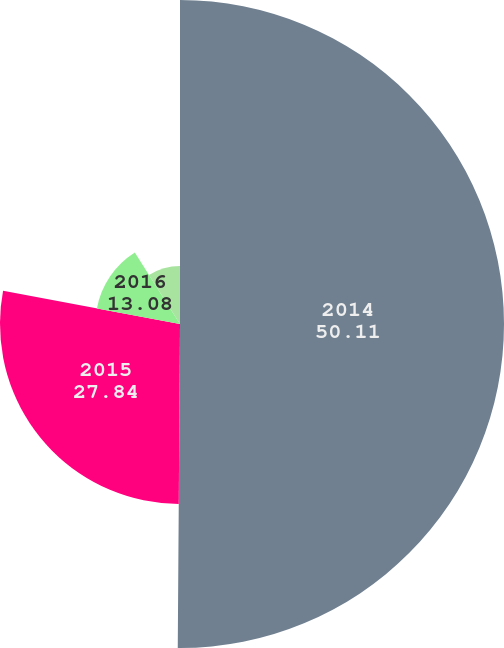Convert chart. <chart><loc_0><loc_0><loc_500><loc_500><pie_chart><fcel>2014<fcel>2015<fcel>2016<fcel>2017<nl><fcel>50.11%<fcel>27.84%<fcel>13.08%<fcel>8.97%<nl></chart> 